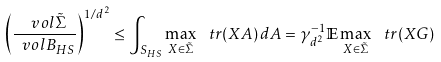Convert formula to latex. <formula><loc_0><loc_0><loc_500><loc_500>\left ( \frac { \ v o l \tilde { \Sigma } } { \ v o l B _ { H S } } \right ) ^ { 1 / d ^ { 2 } } \leq \int _ { S _ { H S } } \max _ { X \in \tilde { \Sigma } } \, \ t r ( X A ) \, d A = \gamma _ { d ^ { 2 } } ^ { - 1 } \mathbb { E } \max _ { X \in \tilde { \Sigma } } \, \ t r ( X G )</formula> 